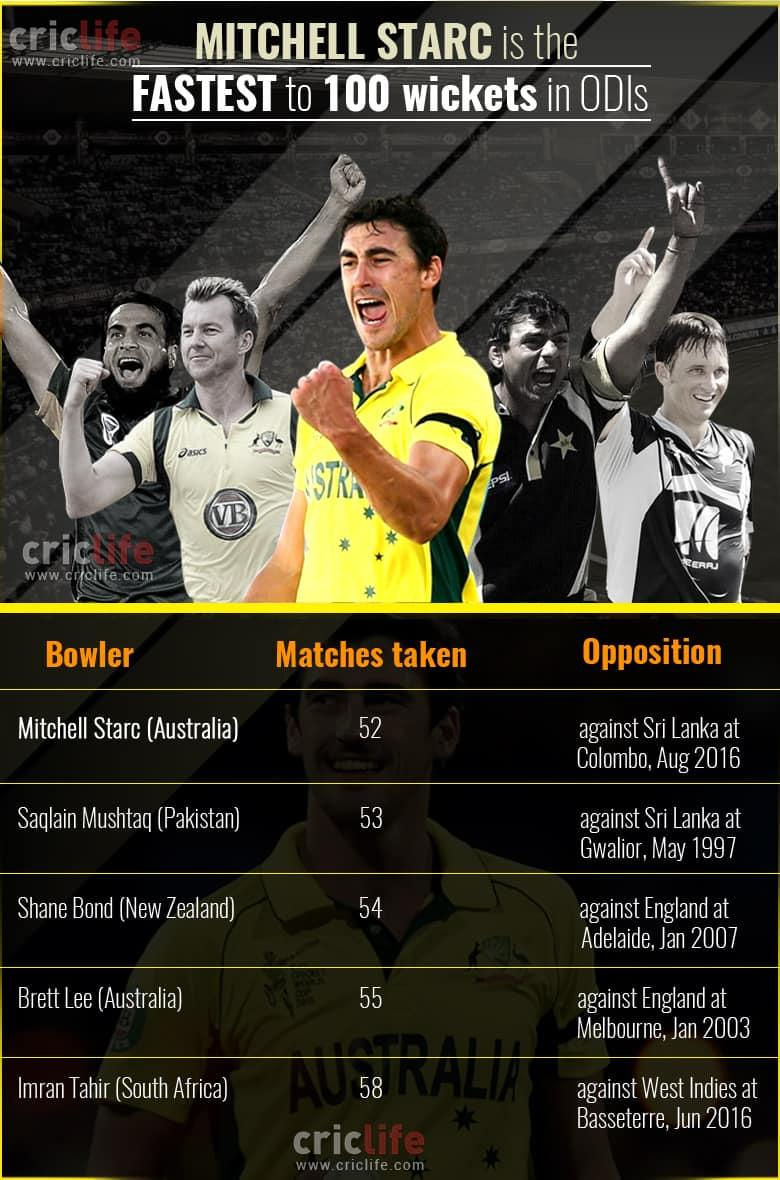Indicate a few pertinent items in this graphic. Saqlain Mushtaq, a player from Pakistan, is the second fastest player to take 100 wickets in One Day Internationals. There are 5 bowlers in this list. 